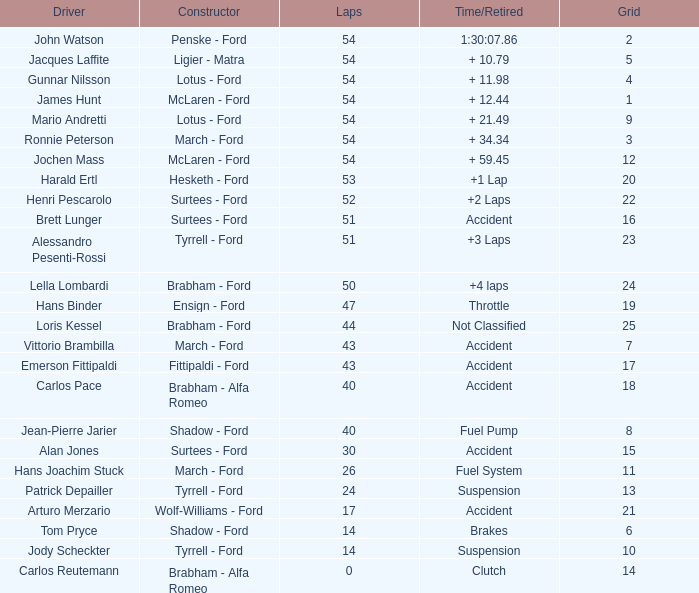How many laps did Emerson Fittipaldi do on a grid larger than 14, and when was the Time/Retired of accident? 1.0. 